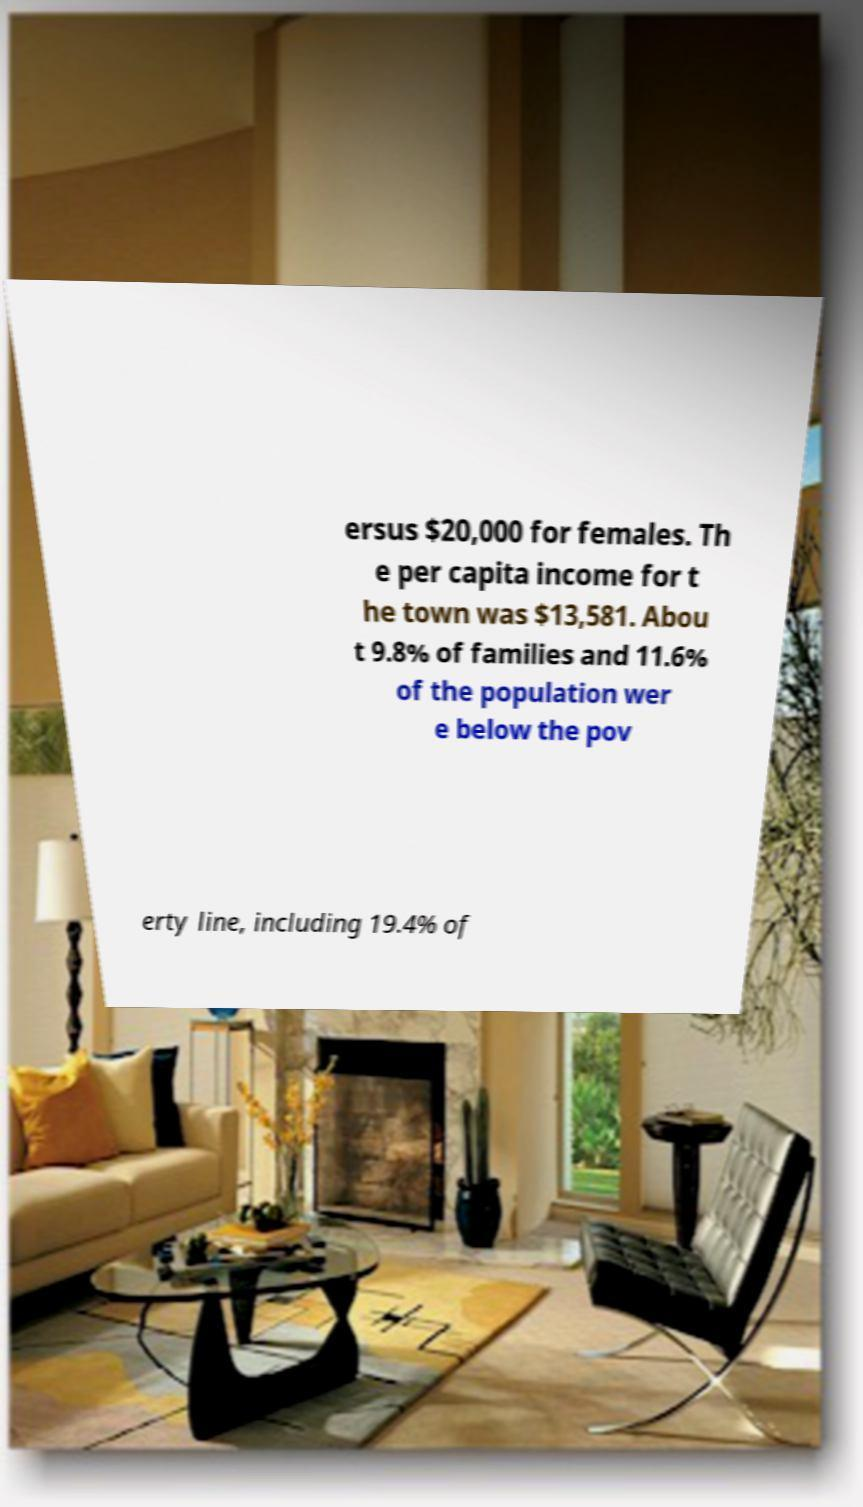Please read and relay the text visible in this image. What does it say? ersus $20,000 for females. Th e per capita income for t he town was $13,581. Abou t 9.8% of families and 11.6% of the population wer e below the pov erty line, including 19.4% of 